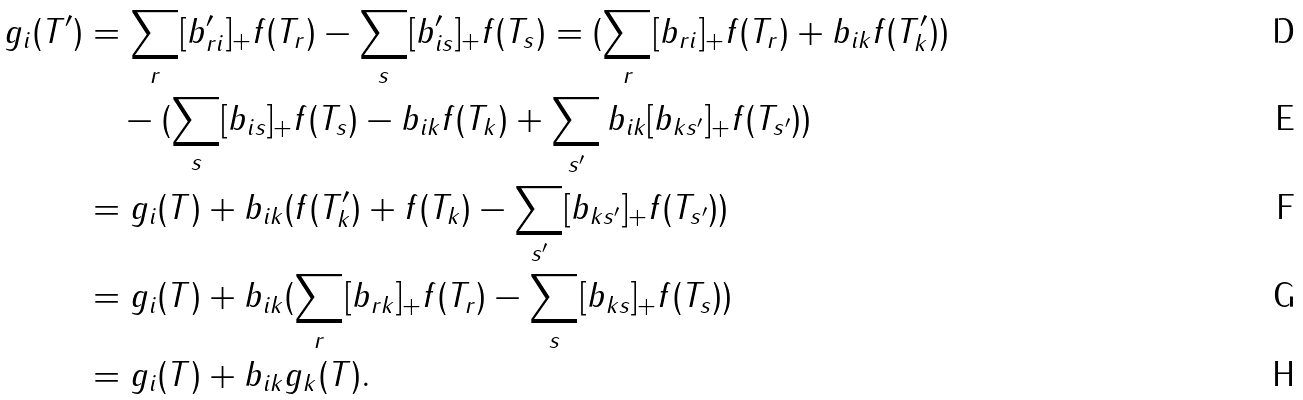Convert formula to latex. <formula><loc_0><loc_0><loc_500><loc_500>g _ { i } ( T ^ { \prime } ) & = \sum _ { r } [ b ^ { \prime } _ { r i } ] _ { + } f ( T _ { r } ) - \sum _ { s } [ b ^ { \prime } _ { i s } ] _ { + } f ( T _ { s } ) = ( \sum _ { r } [ b _ { r i } ] _ { + } f ( T _ { r } ) + b _ { i k } f ( T ^ { \prime } _ { k } ) ) \\ & \quad - ( \sum _ { s } [ b _ { i s } ] _ { + } f ( T _ { s } ) - b _ { i k } f ( T _ { k } ) + \sum _ { s ^ { \prime } } b _ { i k } [ b _ { k s ^ { \prime } } ] _ { + } f ( T _ { s ^ { \prime } } ) ) \\ & = g _ { i } ( T ) + b _ { i k } ( f ( T ^ { \prime } _ { k } ) + f ( T _ { k } ) - \sum _ { s ^ { \prime } } [ b _ { k s ^ { \prime } } ] _ { + } f ( T _ { s ^ { \prime } } ) ) \\ & = g _ { i } ( T ) + b _ { i k } ( \sum _ { r } [ b _ { r k } ] _ { + } f ( T _ { r } ) - \sum _ { s } [ b _ { k s } ] _ { + } f ( T _ { s } ) ) \\ & = g _ { i } ( T ) + b _ { i k } g _ { k } ( T ) .</formula> 